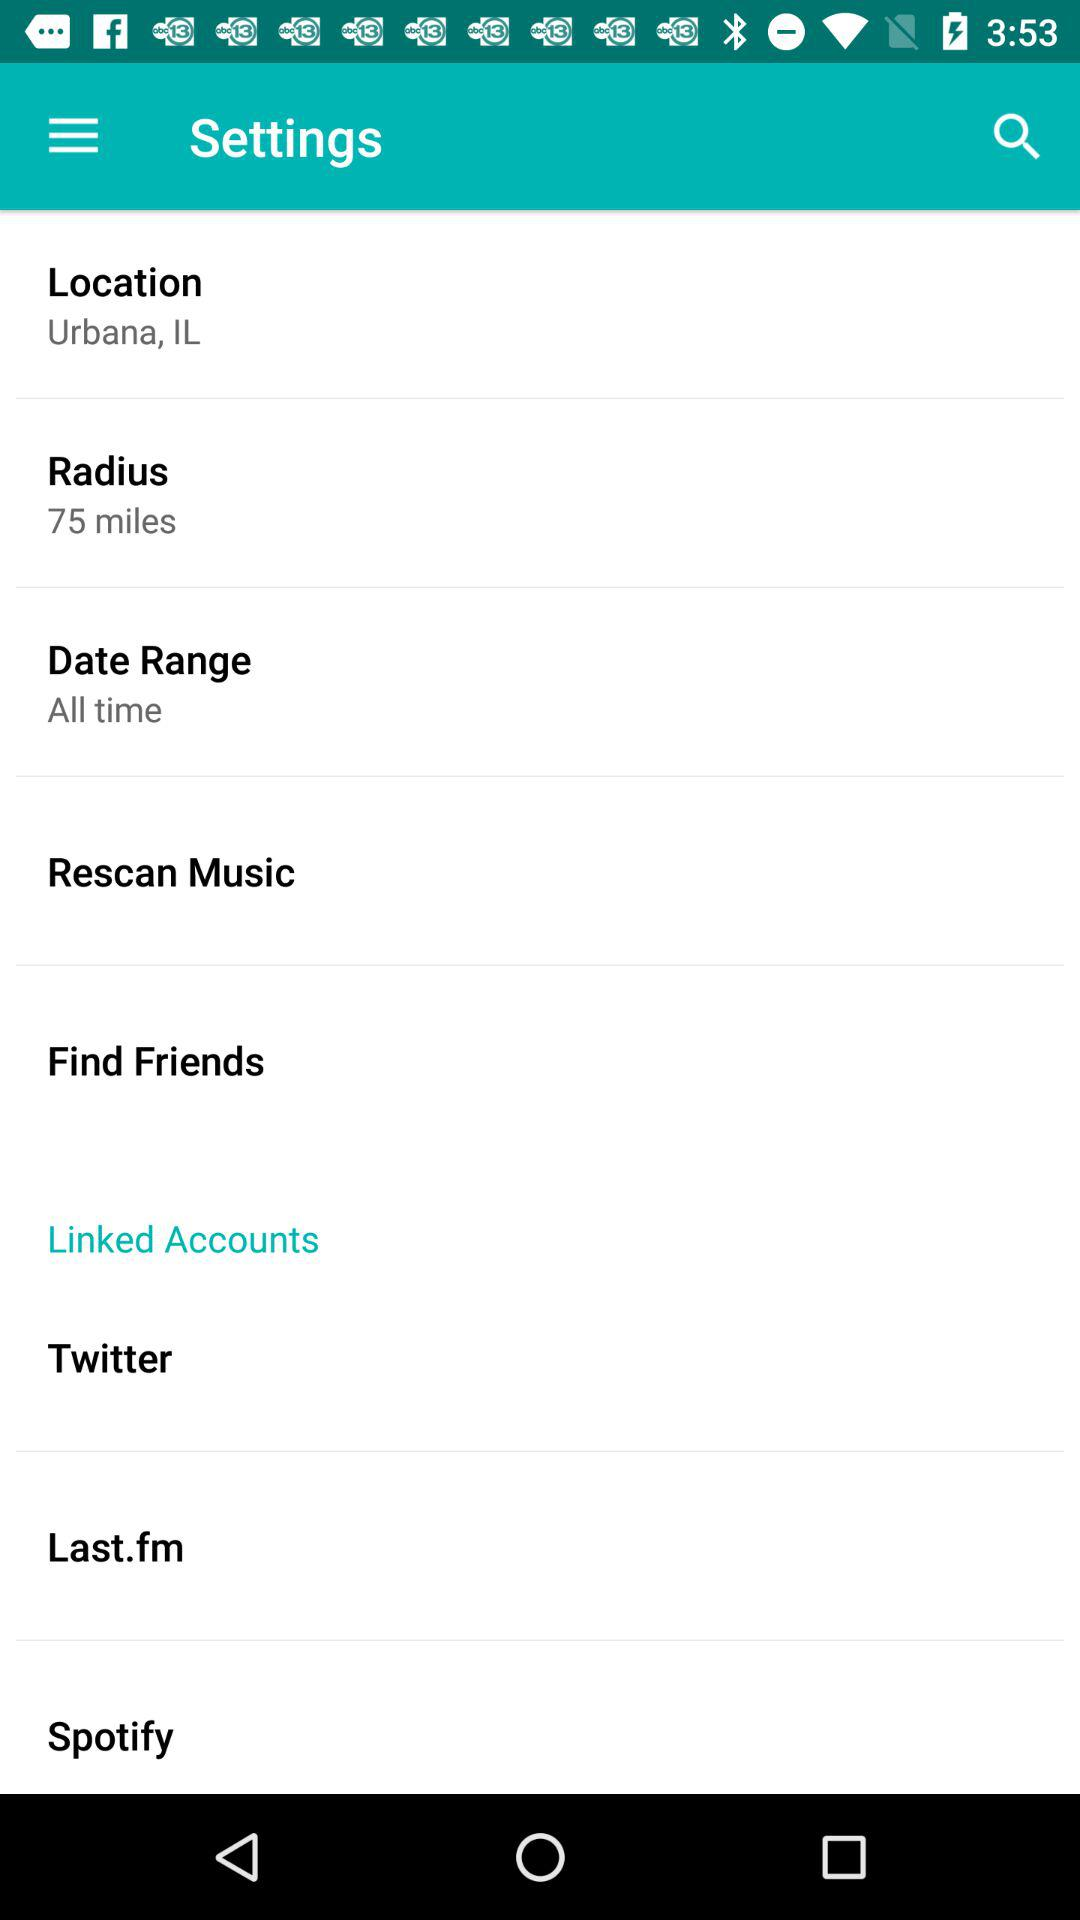What is the Radius? The radius is 75 miles. 